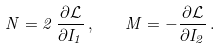<formula> <loc_0><loc_0><loc_500><loc_500>N = 2 \, \frac { \partial { \mathcal { L } } } { \partial I _ { 1 } } \, , \quad M = - \frac { \partial { \mathcal { L } } } { \partial I _ { 2 } } \, .</formula> 